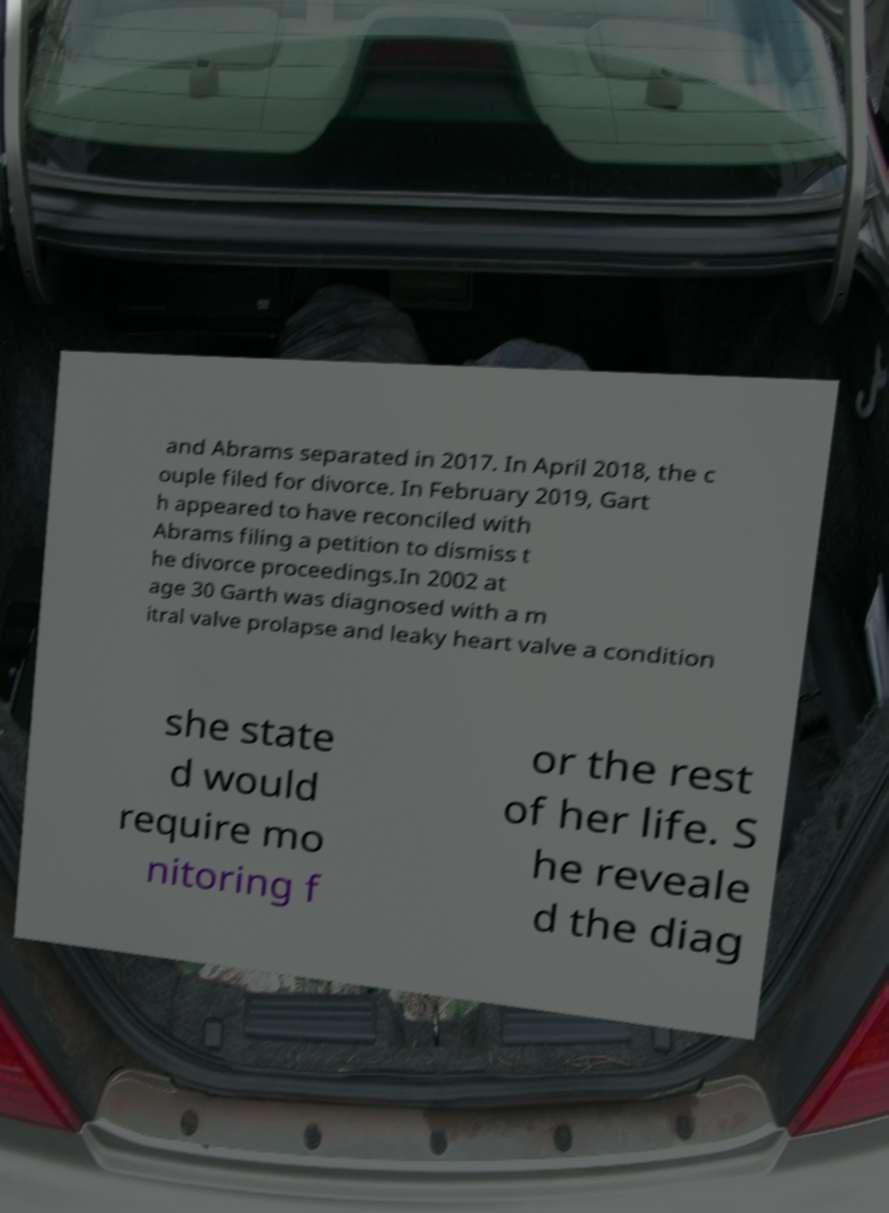Please read and relay the text visible in this image. What does it say? and Abrams separated in 2017. In April 2018, the c ouple filed for divorce. In February 2019, Gart h appeared to have reconciled with Abrams filing a petition to dismiss t he divorce proceedings.In 2002 at age 30 Garth was diagnosed with a m itral valve prolapse and leaky heart valve a condition she state d would require mo nitoring f or the rest of her life. S he reveale d the diag 